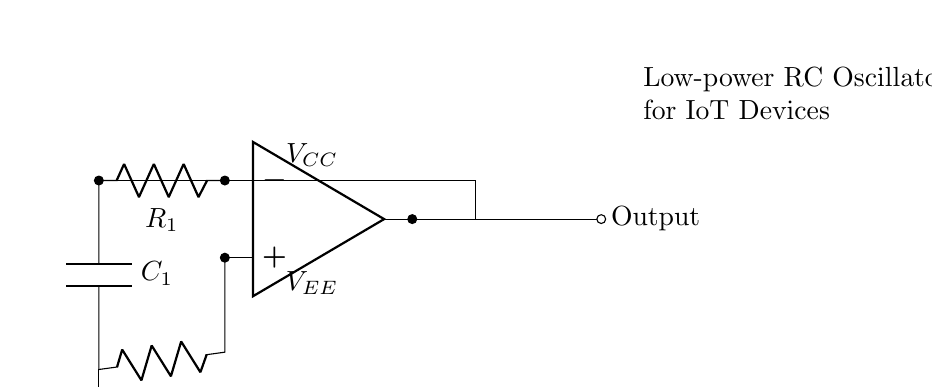What is the type of op-amp used in this circuit? The circuit diagram shows a single operational amplifier symbol, indicating that an op-amp is used, but it does not specify the type. However, it is a general-purpose op-amp suitable for oscillator applications.
Answer: Operational amplifier What are the values of the resistors in this circuit? The circuit diagram labels the resistors as R1 and R2, but does not provide numerical values for them. Since they are not specified in the diagram, thus we cannot provide exact numerical values.
Answer: Not specified What is the role of the capacitor in the oscillator circuit? The capacitor (C1) is crucial in timing and setting the frequency of the oscillator. It stores and releases energy, creating the oscillation required for generating clock signals for IoT devices.
Answer: Timing component What is the output node in this circuit? The output node is indicated by the label "Output," which is located towards the right side of the circuit diagram, connected to the op-amp's output. This is where the oscillation signal can be obtained.
Answer: Output How does the feedback loop work in this oscillator? The feedback loop connects the output of the op-amp back to the inverting input through R1. This configuration allows for proper phase shift and stabilization necessary for sustained oscillations in the circuit.
Answer: Feedback connection What is the purpose of the ground connection in this oscillator? The ground connection provides a common reference point for all the components in the circuit, ensuring that voltage levels are stable and providing a return path for current, which is essential for the operation of the oscillator.
Answer: Common reference point What is the power supply voltage for this circuit? The circuit shows two power supply labels, VCC and VEE, but does not specify exact values. VCC is typically positive and VEE is negative, providing the necessary power for the op-amp operation in an oscillator application.
Answer: Not specified 